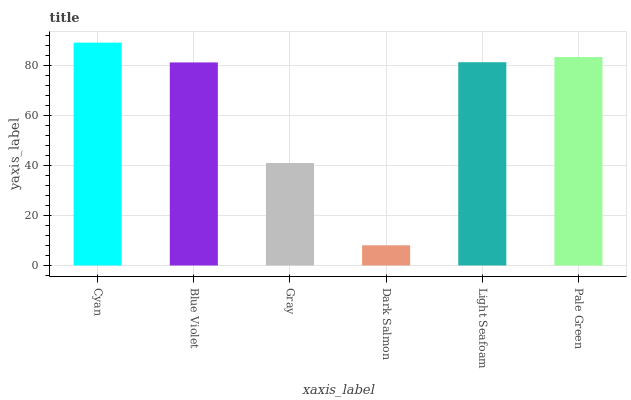Is Dark Salmon the minimum?
Answer yes or no. Yes. Is Cyan the maximum?
Answer yes or no. Yes. Is Blue Violet the minimum?
Answer yes or no. No. Is Blue Violet the maximum?
Answer yes or no. No. Is Cyan greater than Blue Violet?
Answer yes or no. Yes. Is Blue Violet less than Cyan?
Answer yes or no. Yes. Is Blue Violet greater than Cyan?
Answer yes or no. No. Is Cyan less than Blue Violet?
Answer yes or no. No. Is Light Seafoam the high median?
Answer yes or no. Yes. Is Blue Violet the low median?
Answer yes or no. Yes. Is Gray the high median?
Answer yes or no. No. Is Dark Salmon the low median?
Answer yes or no. No. 